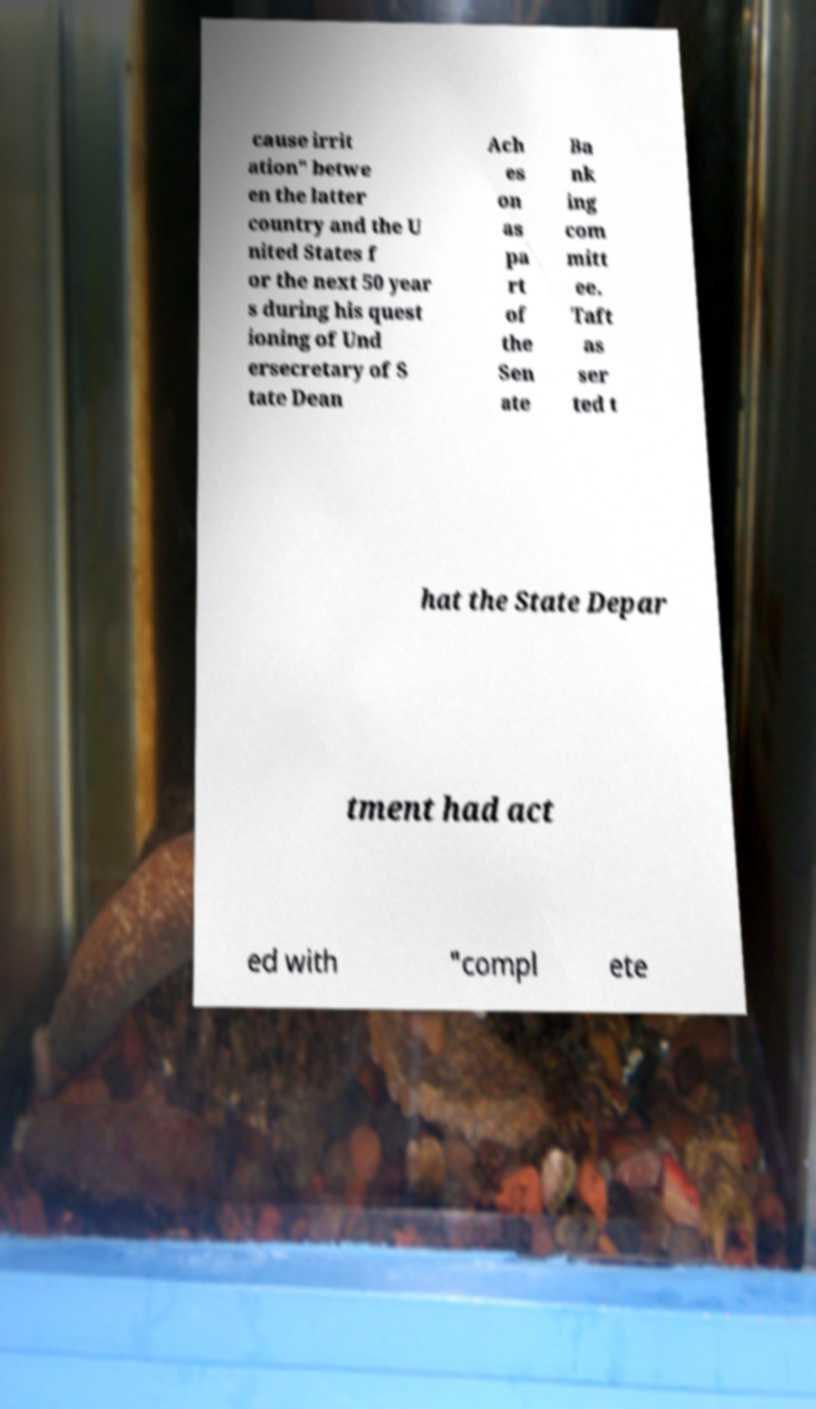Can you read and provide the text displayed in the image?This photo seems to have some interesting text. Can you extract and type it out for me? cause irrit ation" betwe en the latter country and the U nited States f or the next 50 year s during his quest ioning of Und ersecretary of S tate Dean Ach es on as pa rt of the Sen ate Ba nk ing com mitt ee. Taft as ser ted t hat the State Depar tment had act ed with "compl ete 